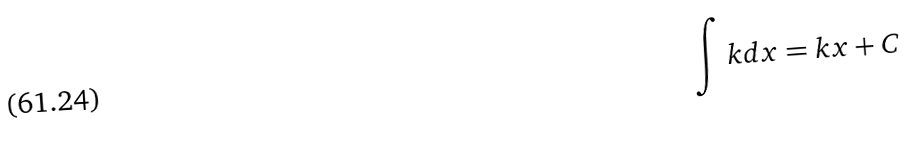<formula> <loc_0><loc_0><loc_500><loc_500>\int k d x = k x + C</formula> 